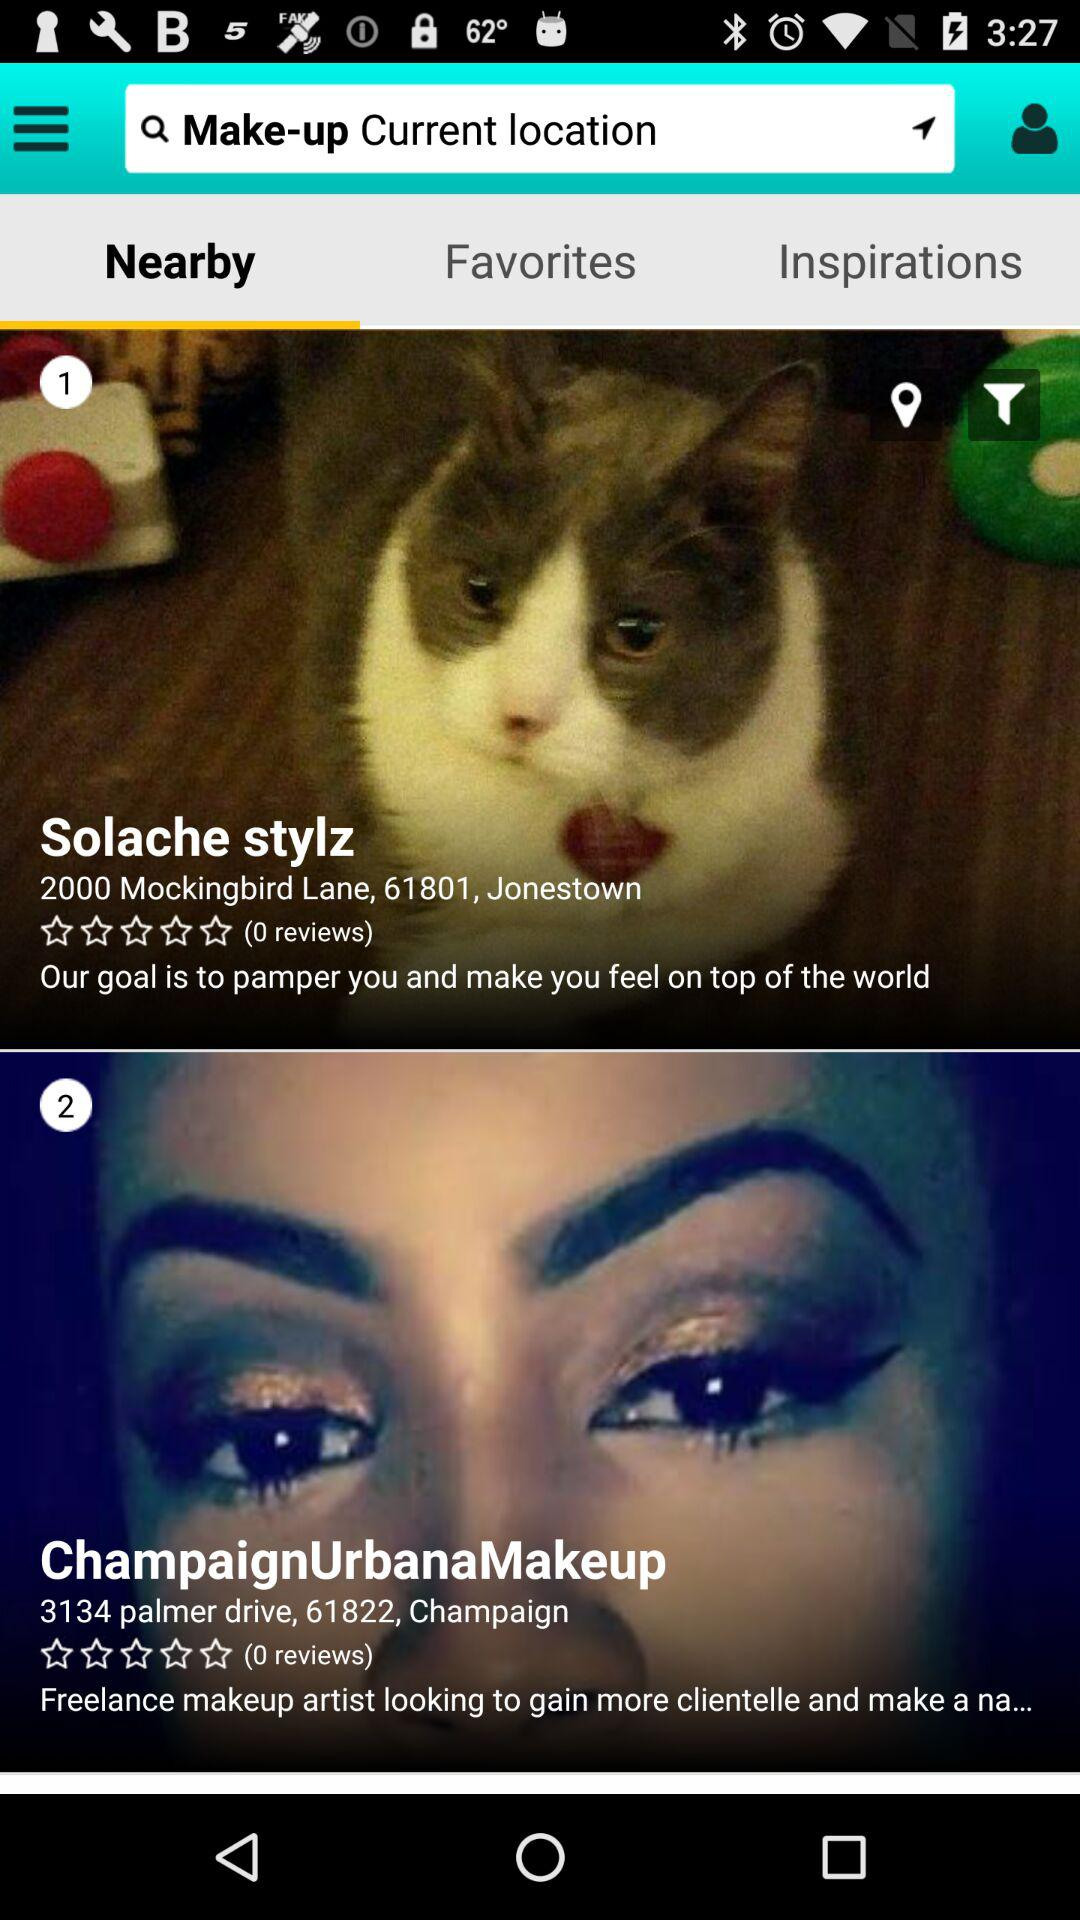How many reviews are there for the Solache stylz? There are 0 reviews. 